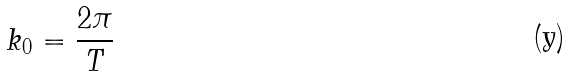<formula> <loc_0><loc_0><loc_500><loc_500>k _ { 0 } = \frac { 2 \pi } { T }</formula> 